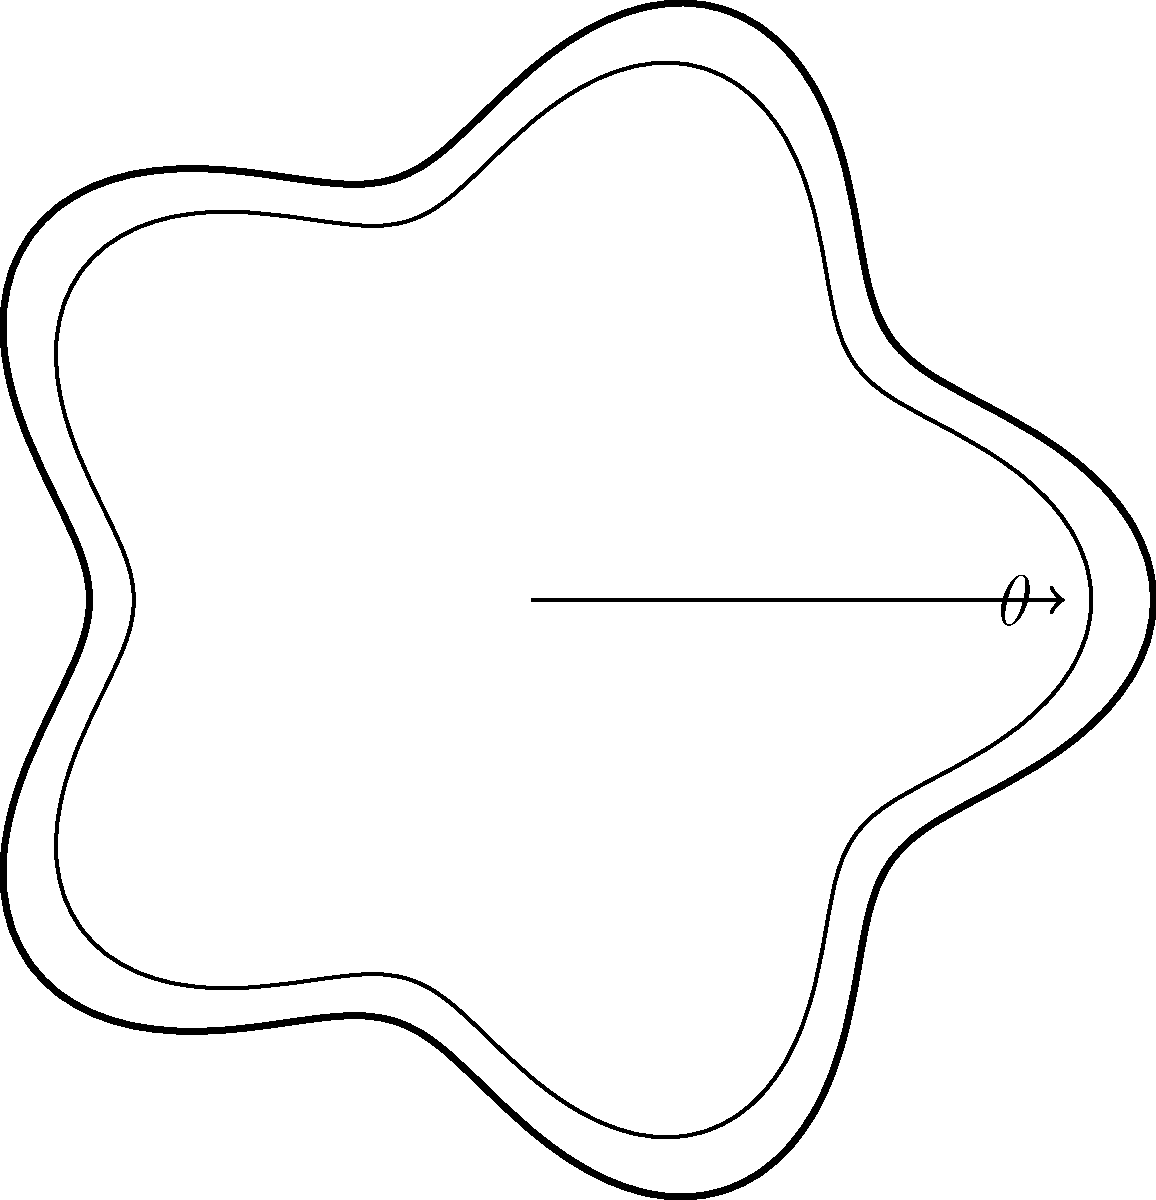In the context of antique book cover design, consider the polar equation $r = 3 + 0.5\cos(5\theta)$. This equation represents the ornate border of a classic leather-bound tome. How many complete lobes or decorative protrusions does this border create around the book cover? To determine the number of lobes in the book cover design, we need to analyze the given polar equation:

1. The equation is $r = 3 + 0.5\cos(5\theta)$

2. The cosine function completes one full cycle every $2\pi$ radians.

3. In this equation, the argument of cosine is $5\theta$. This means the function will complete a full cycle five times faster than a regular cosine function.

4. For one complete revolution around the origin (i.e., $\theta$ going from 0 to $2\pi$), the $5\theta$ term will cause the cosine function to complete 5 full cycles.

5. Each cycle of the cosine function corresponds to one lobe in the graph.

6. Therefore, the border will have 5 complete lobes or decorative protrusions around the book cover.

This design mimics the intricate patterns often found on antique book covers, where symmetry and repetition play crucial roles in creating an aesthetically pleasing appearance.
Answer: 5 lobes 